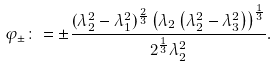Convert formula to latex. <formula><loc_0><loc_0><loc_500><loc_500>\varphi _ { \pm } \colon = \pm \frac { ( \lambda _ { 2 } ^ { 2 } - \lambda _ { 1 } ^ { 2 } ) ^ { \frac { 2 } { 3 } } \left ( \lambda _ { 2 } \left ( \lambda _ { 2 } ^ { 2 } - \lambda _ { 3 } ^ { 2 } \right ) \right ) ^ { \frac { 1 } { 3 } } } { 2 ^ { \frac { 1 } { 3 } } \lambda _ { 2 } ^ { 2 } } .</formula> 